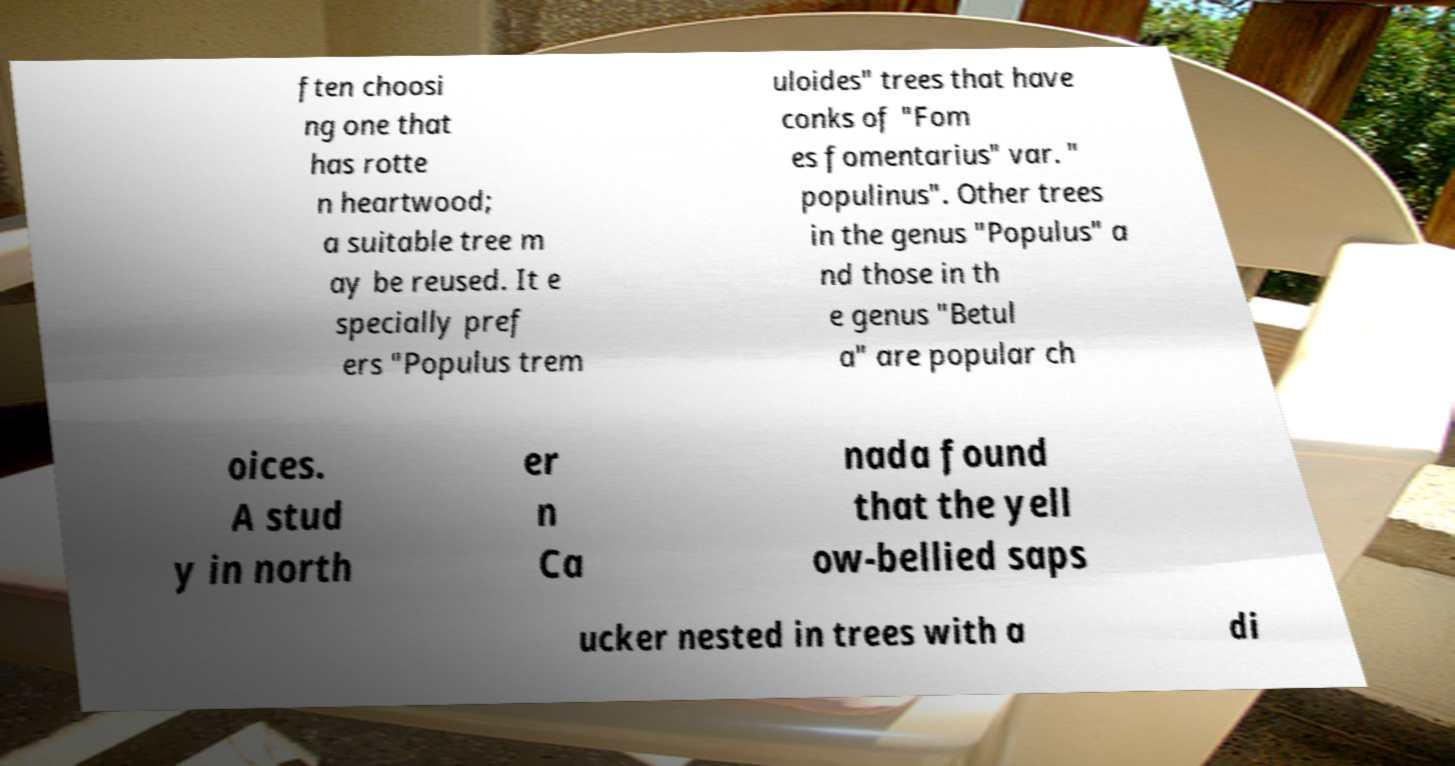What messages or text are displayed in this image? I need them in a readable, typed format. ften choosi ng one that has rotte n heartwood; a suitable tree m ay be reused. It e specially pref ers "Populus trem uloides" trees that have conks of "Fom es fomentarius" var. " populinus". Other trees in the genus "Populus" a nd those in th e genus "Betul a" are popular ch oices. A stud y in north er n Ca nada found that the yell ow-bellied saps ucker nested in trees with a di 